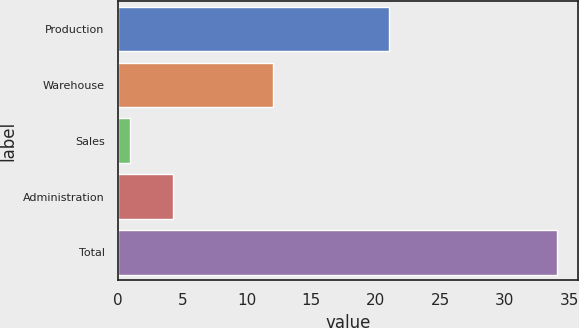<chart> <loc_0><loc_0><loc_500><loc_500><bar_chart><fcel>Production<fcel>Warehouse<fcel>Sales<fcel>Administration<fcel>Total<nl><fcel>21<fcel>12<fcel>0.98<fcel>4.28<fcel>34<nl></chart> 